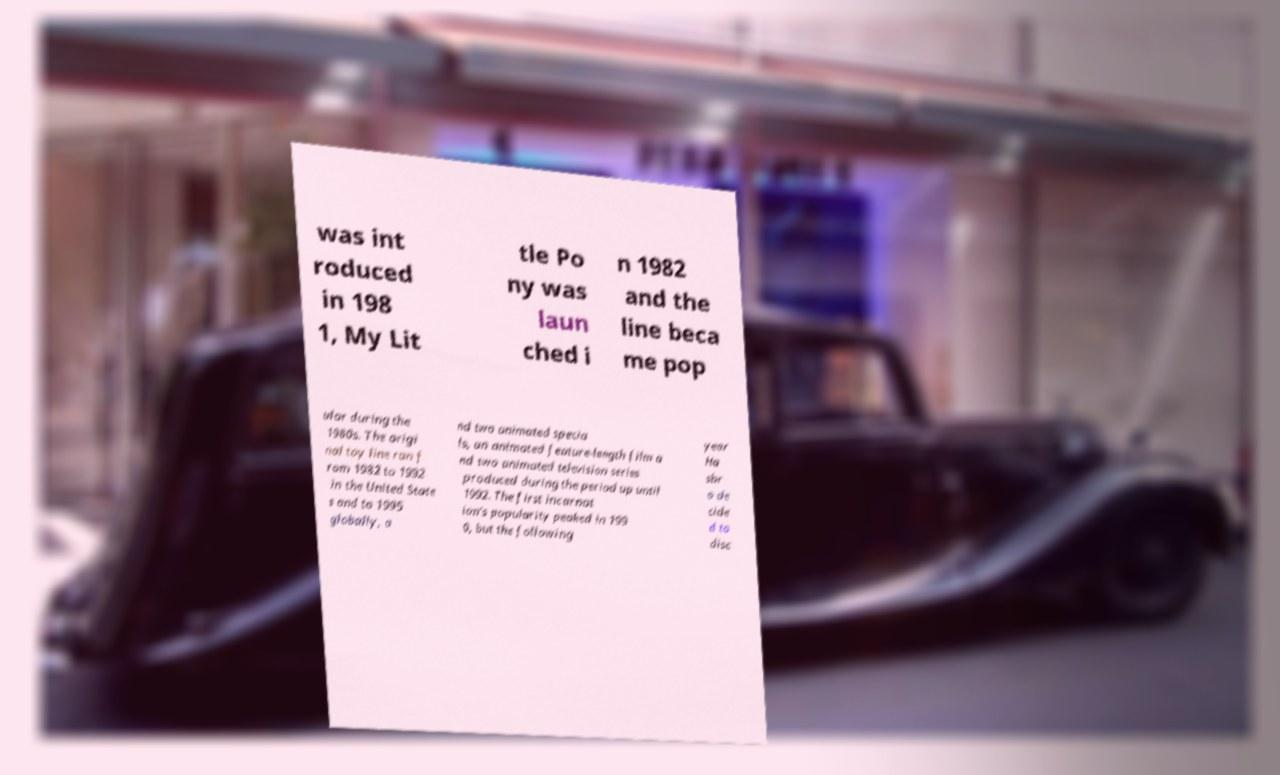For documentation purposes, I need the text within this image transcribed. Could you provide that? was int roduced in 198 1, My Lit tle Po ny was laun ched i n 1982 and the line beca me pop ular during the 1980s. The origi nal toy line ran f rom 1982 to 1992 in the United State s and to 1995 globally, a nd two animated specia ls, an animated feature-length film a nd two animated television series produced during the period up until 1992. The first incarnat ion's popularity peaked in 199 0, but the following year Ha sbr o de cide d to disc 